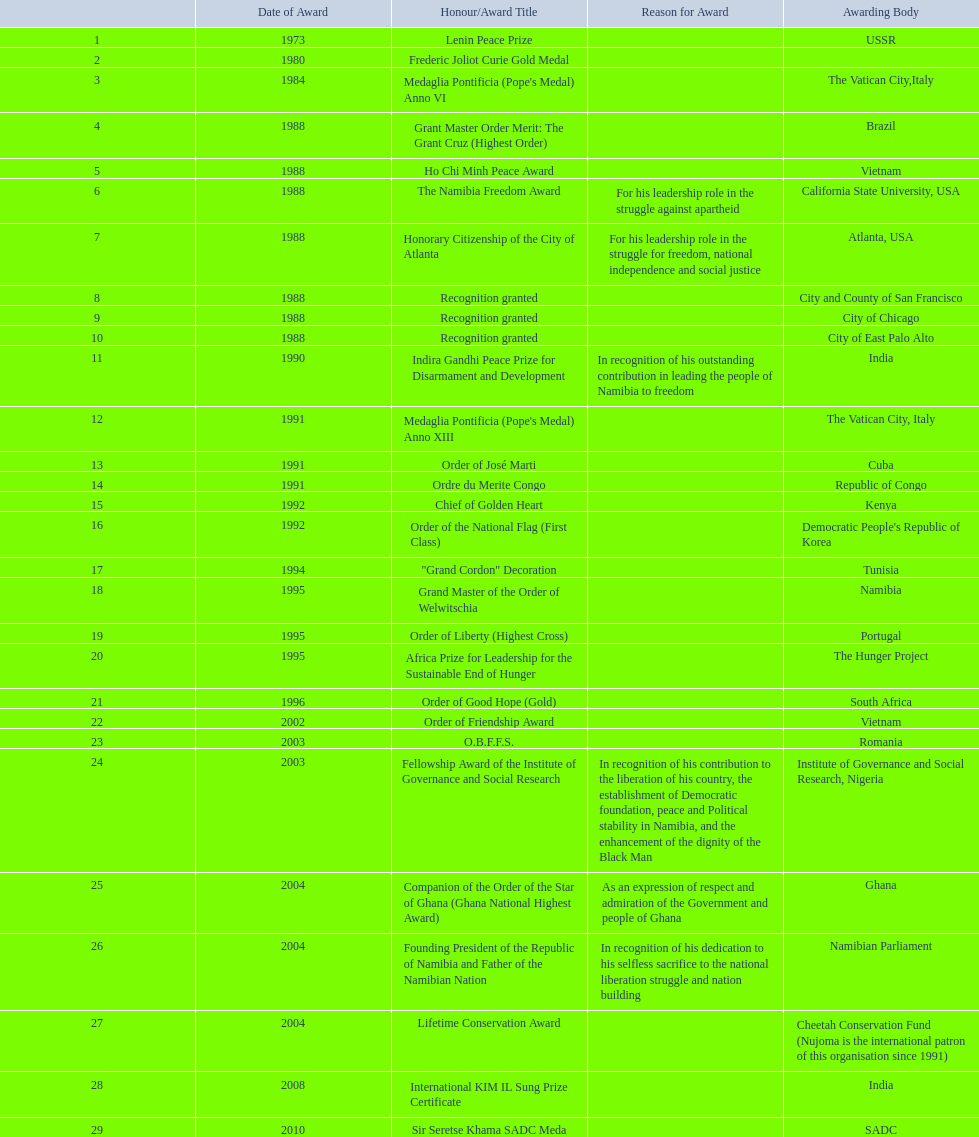Which granting institutions have acknowledged sam nujoma? USSR, , The Vatican City,Italy, Brazil, Vietnam, California State University, USA, Atlanta, USA, City and County of San Francisco, City of Chicago, City of East Palo Alto, India, The Vatican City, Italy, Cuba, Republic of Congo, Kenya, Democratic People's Republic of Korea, Tunisia, Namibia, Portugal, The Hunger Project, South Africa, Vietnam, Romania, Institute of Governance and Social Research, Nigeria, Ghana, Namibian Parliament, Cheetah Conservation Fund (Nujoma is the international patron of this organisation since 1991), India, SADC. And what was the designation of each prize or recognition? Lenin Peace Prize, Frederic Joliot Curie Gold Medal, Medaglia Pontificia (Pope's Medal) Anno VI, Grant Master Order Merit: The Grant Cruz (Highest Order), Ho Chi Minh Peace Award, The Namibia Freedom Award, Honorary Citizenship of the City of Atlanta, Recognition granted, Recognition granted, Recognition granted, Indira Gandhi Peace Prize for Disarmament and Development, Medaglia Pontificia (Pope's Medal) Anno XIII, Order of José Marti, Ordre du Merite Congo, Chief of Golden Heart, Order of the National Flag (First Class), "Grand Cordon" Decoration, Grand Master of the Order of Welwitschia, Order of Liberty (Highest Cross), Africa Prize for Leadership for the Sustainable End of Hunger, Order of Good Hope (Gold), Order of Friendship Award, O.B.F.F.S., Fellowship Award of the Institute of Governance and Social Research, Companion of the Order of the Star of Ghana (Ghana National Highest Award), Founding President of the Republic of Namibia and Father of the Namibian Nation, Lifetime Conservation Award, International KIM IL Sung Prize Certificate, Sir Seretse Khama SADC Meda. From those, which nation conferred him the o.b.f.f.s.? Romania. 